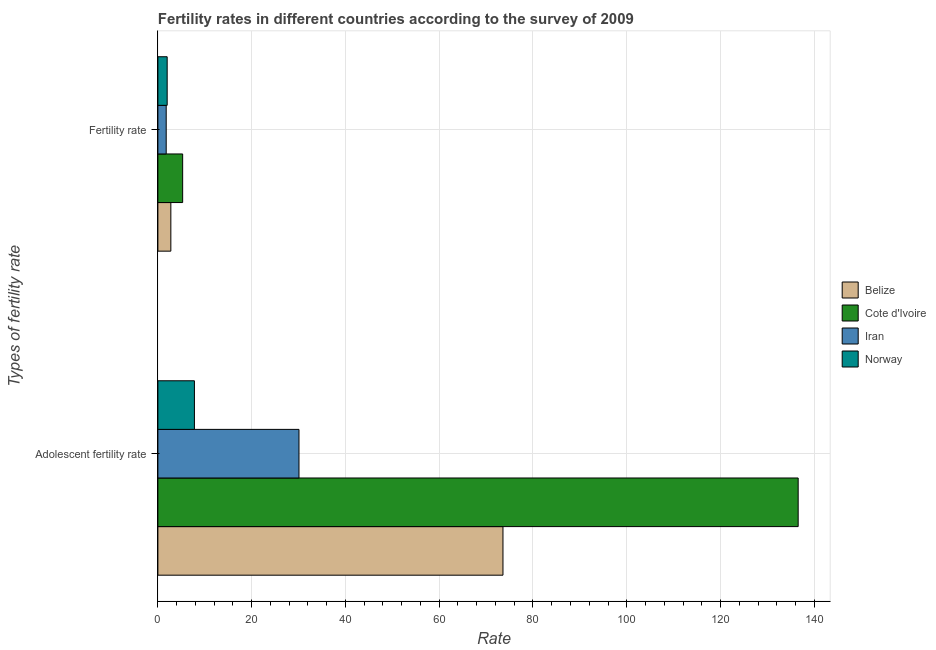How many different coloured bars are there?
Make the answer very short. 4. How many groups of bars are there?
Your response must be concise. 2. Are the number of bars per tick equal to the number of legend labels?
Your answer should be compact. Yes. Are the number of bars on each tick of the Y-axis equal?
Your answer should be very brief. Yes. How many bars are there on the 1st tick from the bottom?
Offer a very short reply. 4. What is the label of the 2nd group of bars from the top?
Provide a short and direct response. Adolescent fertility rate. What is the fertility rate in Iran?
Make the answer very short. 1.77. Across all countries, what is the maximum adolescent fertility rate?
Your answer should be very brief. 136.56. Across all countries, what is the minimum fertility rate?
Provide a short and direct response. 1.77. In which country was the fertility rate maximum?
Provide a short and direct response. Cote d'Ivoire. In which country was the fertility rate minimum?
Offer a very short reply. Iran. What is the total adolescent fertility rate in the graph?
Ensure brevity in your answer.  248.04. What is the difference between the adolescent fertility rate in Norway and that in Iran?
Offer a very short reply. -22.3. What is the difference between the fertility rate in Iran and the adolescent fertility rate in Cote d'Ivoire?
Keep it short and to the point. -134.79. What is the average fertility rate per country?
Your response must be concise. 2.95. What is the difference between the adolescent fertility rate and fertility rate in Cote d'Ivoire?
Give a very brief answer. 131.28. What is the ratio of the adolescent fertility rate in Norway to that in Cote d'Ivoire?
Provide a short and direct response. 0.06. In how many countries, is the fertility rate greater than the average fertility rate taken over all countries?
Provide a succinct answer. 1. What does the 3rd bar from the top in Fertility rate represents?
Ensure brevity in your answer.  Cote d'Ivoire. What does the 2nd bar from the bottom in Adolescent fertility rate represents?
Offer a terse response. Cote d'Ivoire. Are all the bars in the graph horizontal?
Make the answer very short. Yes. How many countries are there in the graph?
Offer a very short reply. 4. What is the difference between two consecutive major ticks on the X-axis?
Your answer should be compact. 20. Are the values on the major ticks of X-axis written in scientific E-notation?
Provide a short and direct response. No. Does the graph contain grids?
Your answer should be compact. Yes. What is the title of the graph?
Give a very brief answer. Fertility rates in different countries according to the survey of 2009. Does "West Bank and Gaza" appear as one of the legend labels in the graph?
Your response must be concise. No. What is the label or title of the X-axis?
Offer a very short reply. Rate. What is the label or title of the Y-axis?
Ensure brevity in your answer.  Types of fertility rate. What is the Rate of Belize in Adolescent fertility rate?
Your answer should be very brief. 73.6. What is the Rate of Cote d'Ivoire in Adolescent fertility rate?
Provide a succinct answer. 136.56. What is the Rate of Iran in Adolescent fertility rate?
Make the answer very short. 30.09. What is the Rate in Norway in Adolescent fertility rate?
Make the answer very short. 7.79. What is the Rate in Belize in Fertility rate?
Your answer should be compact. 2.76. What is the Rate in Cote d'Ivoire in Fertility rate?
Provide a succinct answer. 5.28. What is the Rate in Iran in Fertility rate?
Provide a short and direct response. 1.77. What is the Rate of Norway in Fertility rate?
Offer a very short reply. 1.98. Across all Types of fertility rate, what is the maximum Rate of Belize?
Provide a succinct answer. 73.6. Across all Types of fertility rate, what is the maximum Rate of Cote d'Ivoire?
Ensure brevity in your answer.  136.56. Across all Types of fertility rate, what is the maximum Rate in Iran?
Ensure brevity in your answer.  30.09. Across all Types of fertility rate, what is the maximum Rate of Norway?
Offer a terse response. 7.79. Across all Types of fertility rate, what is the minimum Rate of Belize?
Keep it short and to the point. 2.76. Across all Types of fertility rate, what is the minimum Rate of Cote d'Ivoire?
Provide a succinct answer. 5.28. Across all Types of fertility rate, what is the minimum Rate in Iran?
Ensure brevity in your answer.  1.77. Across all Types of fertility rate, what is the minimum Rate of Norway?
Provide a succinct answer. 1.98. What is the total Rate in Belize in the graph?
Make the answer very short. 76.36. What is the total Rate in Cote d'Ivoire in the graph?
Provide a succinct answer. 141.84. What is the total Rate in Iran in the graph?
Offer a very short reply. 31.86. What is the total Rate of Norway in the graph?
Offer a terse response. 9.77. What is the difference between the Rate in Belize in Adolescent fertility rate and that in Fertility rate?
Offer a very short reply. 70.84. What is the difference between the Rate in Cote d'Ivoire in Adolescent fertility rate and that in Fertility rate?
Provide a short and direct response. 131.28. What is the difference between the Rate of Iran in Adolescent fertility rate and that in Fertility rate?
Keep it short and to the point. 28.32. What is the difference between the Rate in Norway in Adolescent fertility rate and that in Fertility rate?
Ensure brevity in your answer.  5.81. What is the difference between the Rate of Belize in Adolescent fertility rate and the Rate of Cote d'Ivoire in Fertility rate?
Your answer should be very brief. 68.32. What is the difference between the Rate in Belize in Adolescent fertility rate and the Rate in Iran in Fertility rate?
Provide a short and direct response. 71.83. What is the difference between the Rate in Belize in Adolescent fertility rate and the Rate in Norway in Fertility rate?
Provide a short and direct response. 71.62. What is the difference between the Rate of Cote d'Ivoire in Adolescent fertility rate and the Rate of Iran in Fertility rate?
Your answer should be compact. 134.79. What is the difference between the Rate of Cote d'Ivoire in Adolescent fertility rate and the Rate of Norway in Fertility rate?
Make the answer very short. 134.58. What is the difference between the Rate of Iran in Adolescent fertility rate and the Rate of Norway in Fertility rate?
Offer a very short reply. 28.11. What is the average Rate in Belize per Types of fertility rate?
Provide a succinct answer. 38.18. What is the average Rate of Cote d'Ivoire per Types of fertility rate?
Your answer should be compact. 70.92. What is the average Rate of Iran per Types of fertility rate?
Keep it short and to the point. 15.93. What is the average Rate in Norway per Types of fertility rate?
Ensure brevity in your answer.  4.89. What is the difference between the Rate in Belize and Rate in Cote d'Ivoire in Adolescent fertility rate?
Make the answer very short. -62.96. What is the difference between the Rate of Belize and Rate of Iran in Adolescent fertility rate?
Offer a terse response. 43.51. What is the difference between the Rate in Belize and Rate in Norway in Adolescent fertility rate?
Keep it short and to the point. 65.81. What is the difference between the Rate of Cote d'Ivoire and Rate of Iran in Adolescent fertility rate?
Ensure brevity in your answer.  106.47. What is the difference between the Rate in Cote d'Ivoire and Rate in Norway in Adolescent fertility rate?
Your answer should be very brief. 128.77. What is the difference between the Rate of Iran and Rate of Norway in Adolescent fertility rate?
Give a very brief answer. 22.3. What is the difference between the Rate in Belize and Rate in Cote d'Ivoire in Fertility rate?
Your response must be concise. -2.52. What is the difference between the Rate in Belize and Rate in Iran in Fertility rate?
Give a very brief answer. 0.99. What is the difference between the Rate in Belize and Rate in Norway in Fertility rate?
Keep it short and to the point. 0.78. What is the difference between the Rate of Cote d'Ivoire and Rate of Iran in Fertility rate?
Offer a terse response. 3.51. What is the difference between the Rate in Cote d'Ivoire and Rate in Norway in Fertility rate?
Your answer should be very brief. 3.3. What is the difference between the Rate in Iran and Rate in Norway in Fertility rate?
Make the answer very short. -0.21. What is the ratio of the Rate of Belize in Adolescent fertility rate to that in Fertility rate?
Offer a terse response. 26.65. What is the ratio of the Rate in Cote d'Ivoire in Adolescent fertility rate to that in Fertility rate?
Ensure brevity in your answer.  25.85. What is the ratio of the Rate of Iran in Adolescent fertility rate to that in Fertility rate?
Your response must be concise. 16.98. What is the ratio of the Rate of Norway in Adolescent fertility rate to that in Fertility rate?
Provide a short and direct response. 3.94. What is the difference between the highest and the second highest Rate in Belize?
Your answer should be very brief. 70.84. What is the difference between the highest and the second highest Rate in Cote d'Ivoire?
Give a very brief answer. 131.28. What is the difference between the highest and the second highest Rate in Iran?
Offer a very short reply. 28.32. What is the difference between the highest and the second highest Rate in Norway?
Offer a very short reply. 5.81. What is the difference between the highest and the lowest Rate of Belize?
Your response must be concise. 70.84. What is the difference between the highest and the lowest Rate of Cote d'Ivoire?
Provide a short and direct response. 131.28. What is the difference between the highest and the lowest Rate of Iran?
Offer a very short reply. 28.32. What is the difference between the highest and the lowest Rate in Norway?
Offer a terse response. 5.81. 